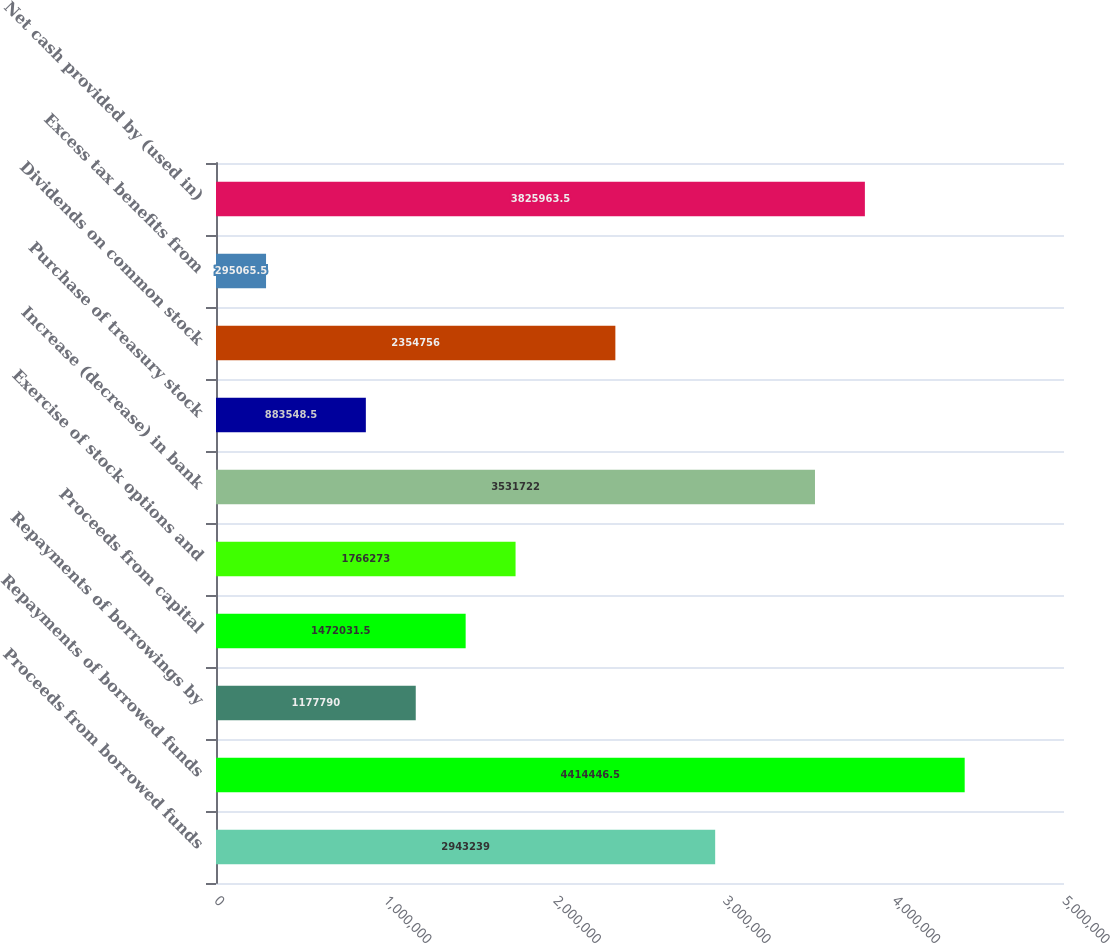<chart> <loc_0><loc_0><loc_500><loc_500><bar_chart><fcel>Proceeds from borrowed funds<fcel>Repayments of borrowed funds<fcel>Repayments of borrowings by<fcel>Proceeds from capital<fcel>Exercise of stock options and<fcel>Increase (decrease) in bank<fcel>Purchase of treasury stock<fcel>Dividends on common stock<fcel>Excess tax benefits from<fcel>Net cash provided by (used in)<nl><fcel>2.94324e+06<fcel>4.41445e+06<fcel>1.17779e+06<fcel>1.47203e+06<fcel>1.76627e+06<fcel>3.53172e+06<fcel>883548<fcel>2.35476e+06<fcel>295066<fcel>3.82596e+06<nl></chart> 